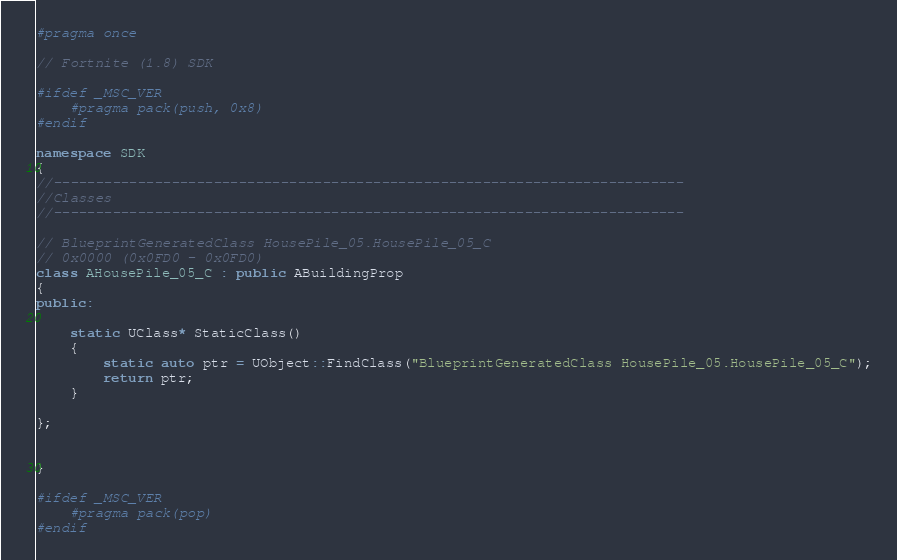Convert code to text. <code><loc_0><loc_0><loc_500><loc_500><_C++_>#pragma once

// Fortnite (1.8) SDK

#ifdef _MSC_VER
	#pragma pack(push, 0x8)
#endif

namespace SDK
{
//---------------------------------------------------------------------------
//Classes
//---------------------------------------------------------------------------

// BlueprintGeneratedClass HousePile_05.HousePile_05_C
// 0x0000 (0x0FD0 - 0x0FD0)
class AHousePile_05_C : public ABuildingProp
{
public:

	static UClass* StaticClass()
	{
		static auto ptr = UObject::FindClass("BlueprintGeneratedClass HousePile_05.HousePile_05_C");
		return ptr;
	}

};


}

#ifdef _MSC_VER
	#pragma pack(pop)
#endif
</code> 